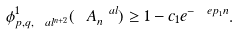<formula> <loc_0><loc_0><loc_500><loc_500>\phi _ { p , q , \ a l ^ { n + 2 } } ^ { 1 } ( \ A ^ { \ a l } _ { n } ) \geq 1 - c _ { 1 } e ^ { - \ e p _ { 1 } n } .</formula> 